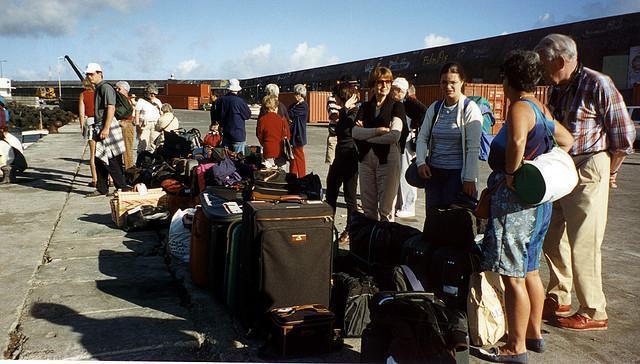How many people can you see?
Give a very brief answer. 7. How many suitcases are there?
Give a very brief answer. 4. How many backpacks are in the photo?
Give a very brief answer. 2. 